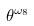Convert formula to latex. <formula><loc_0><loc_0><loc_500><loc_500>\theta ^ { \omega _ { 8 } }</formula> 